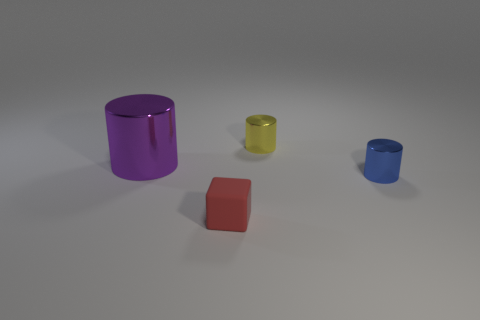There is a tiny metal thing behind the thing that is left of the tiny matte thing on the right side of the big purple metallic cylinder; what is its shape?
Provide a succinct answer. Cylinder. What number of blue metallic things are the same size as the matte thing?
Offer a terse response. 1. Are there any tiny cylinders to the left of the tiny cylinder that is to the left of the blue cylinder?
Provide a succinct answer. No. How many things are tiny red cubes or gray matte cylinders?
Ensure brevity in your answer.  1. What is the color of the tiny metal thing behind the metallic object to the left of the tiny metal thing behind the tiny blue cylinder?
Make the answer very short. Yellow. Is there anything else of the same color as the large shiny cylinder?
Keep it short and to the point. No. Do the red matte block and the purple metal cylinder have the same size?
Your answer should be very brief. No. How many objects are either metal objects that are to the right of the small red cube or objects that are on the right side of the big purple cylinder?
Your answer should be compact. 3. There is a tiny cylinder that is behind the small cylinder in front of the purple shiny cylinder; what is it made of?
Ensure brevity in your answer.  Metal. How many other objects are there of the same material as the small blue cylinder?
Your answer should be compact. 2. 